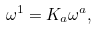Convert formula to latex. <formula><loc_0><loc_0><loc_500><loc_500>\omega ^ { 1 } = K _ { a } \omega ^ { a } ,</formula> 